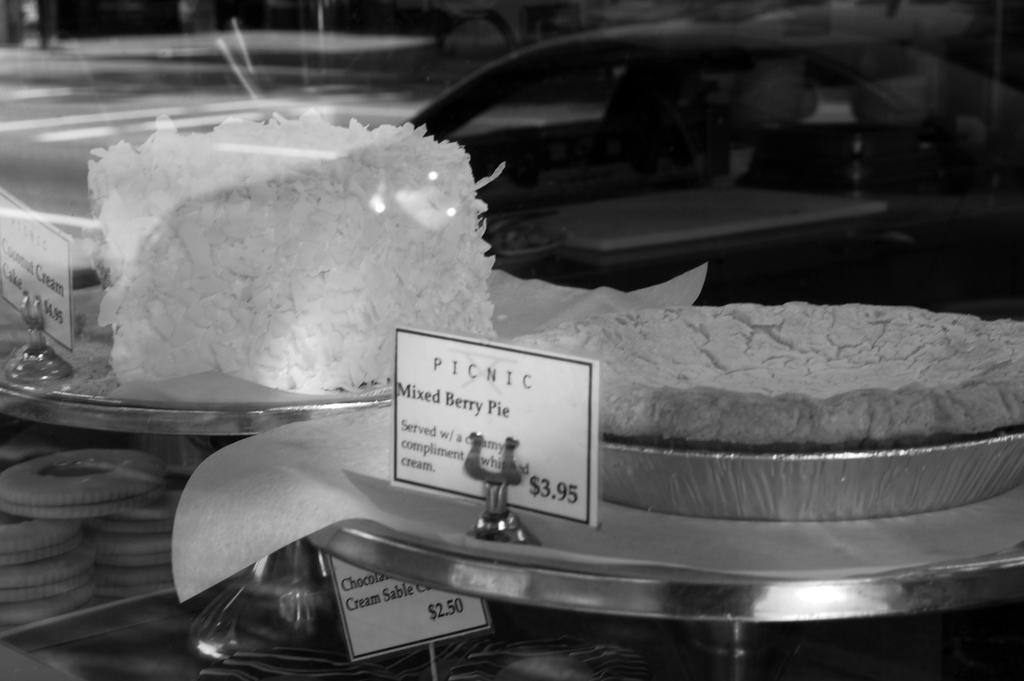What type of food items are on plates in the image? There are desserts on plates in the image. How can customers identify the desserts in the image? There are name boards associated with the desserts in the image. What other food items can be seen in the image? Other food items are visible at the bottom of the image. What type of establishment might the image depict? The image appears to depict a shop. How does the bee interact with the desserts in the image? There are no bees present in the image; it only features desserts on plates, name boards, and other food items. 